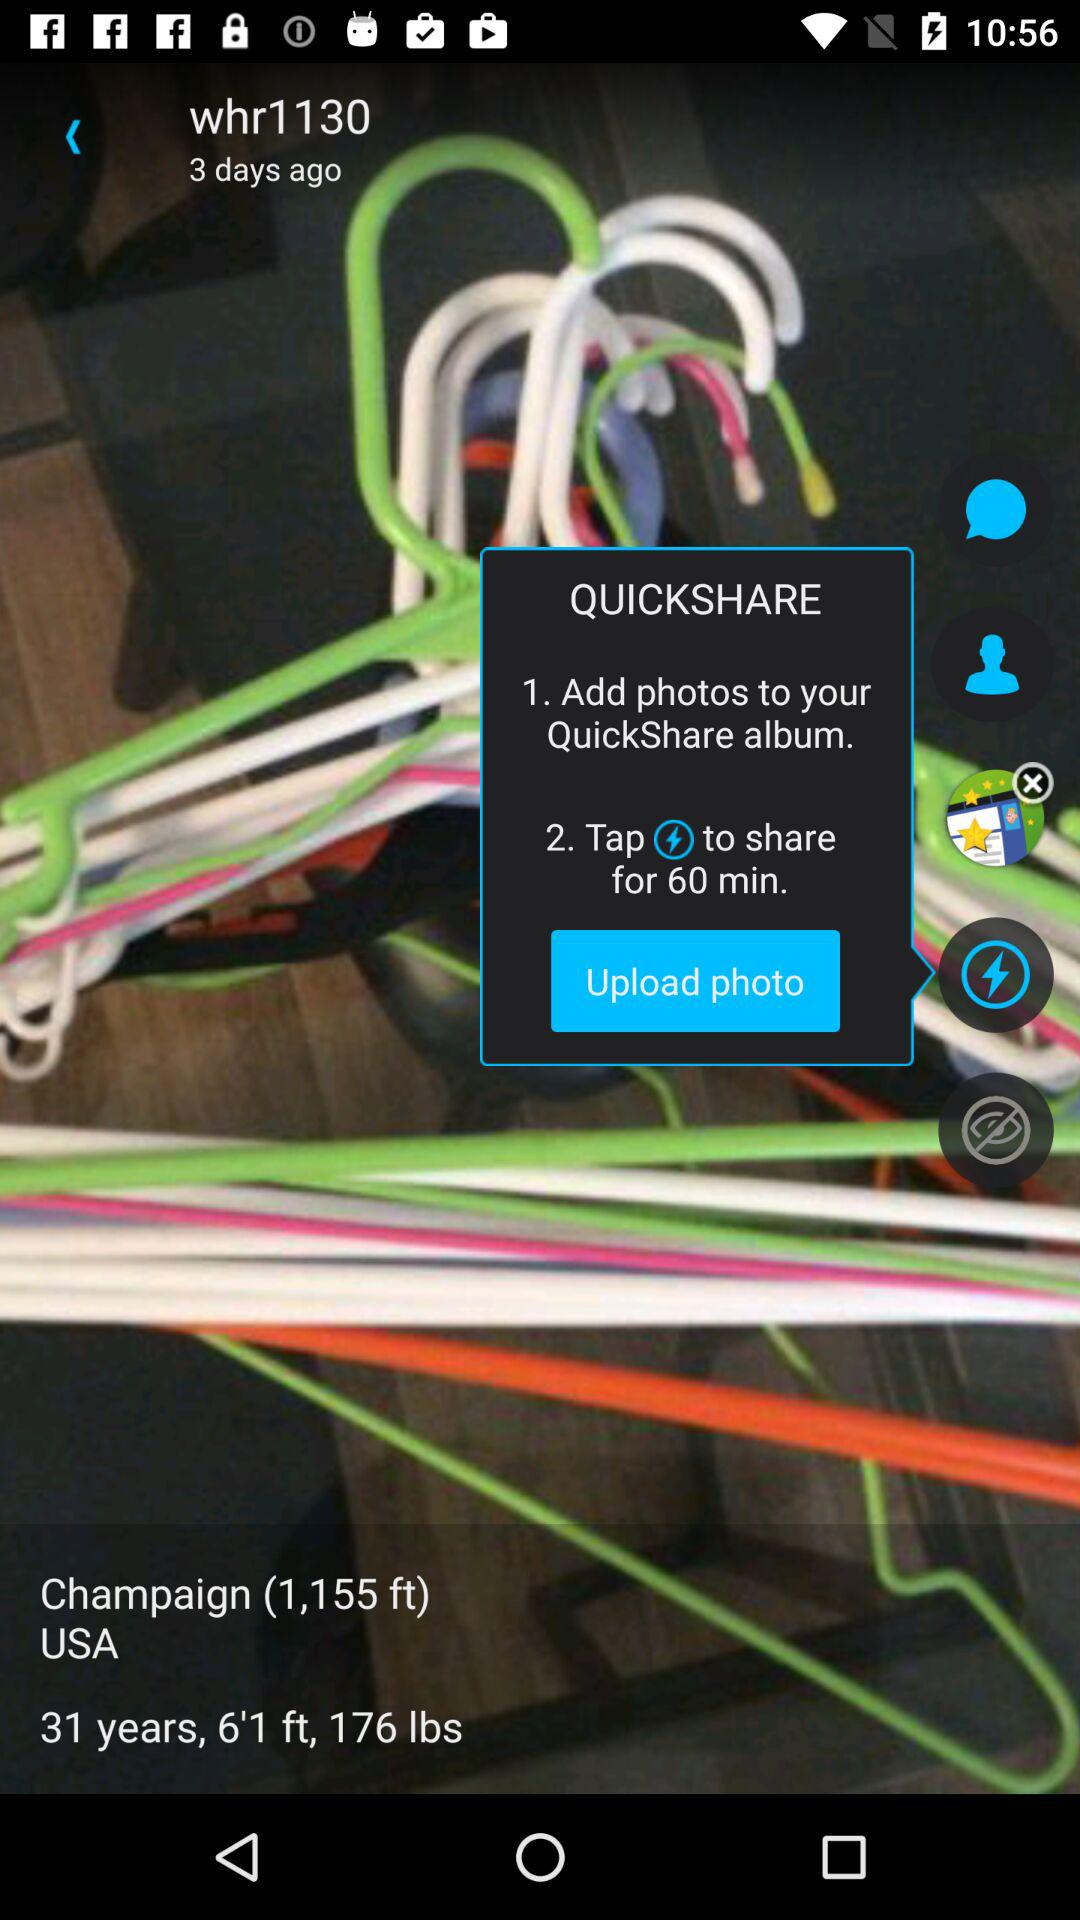What is the height? The height is 6'1". 